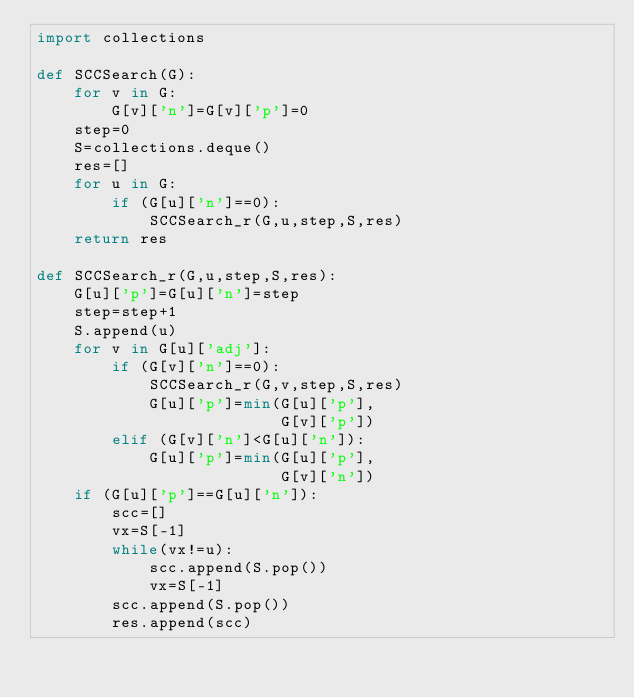Convert code to text. <code><loc_0><loc_0><loc_500><loc_500><_Python_>import collections

def SCCSearch(G):
    for v in G:
        G[v]['n']=G[v]['p']=0
    step=0
    S=collections.deque()
    res=[]
    for u in G:
        if (G[u]['n']==0):
            SCCSearch_r(G,u,step,S,res)
    return res

def SCCSearch_r(G,u,step,S,res):
    G[u]['p']=G[u]['n']=step
    step=step+1
    S.append(u)
    for v in G[u]['adj']:
        if (G[v]['n']==0):
            SCCSearch_r(G,v,step,S,res)
            G[u]['p']=min(G[u]['p'],
                          G[v]['p'])
        elif (G[v]['n']<G[u]['n']):
            G[u]['p']=min(G[u]['p'],
                          G[v]['n'])
    if (G[u]['p']==G[u]['n']):
        scc=[]
        vx=S[-1]
        while(vx!=u):
            scc.append(S.pop())
            vx=S[-1]
        scc.append(S.pop())
        res.append(scc)


</code> 